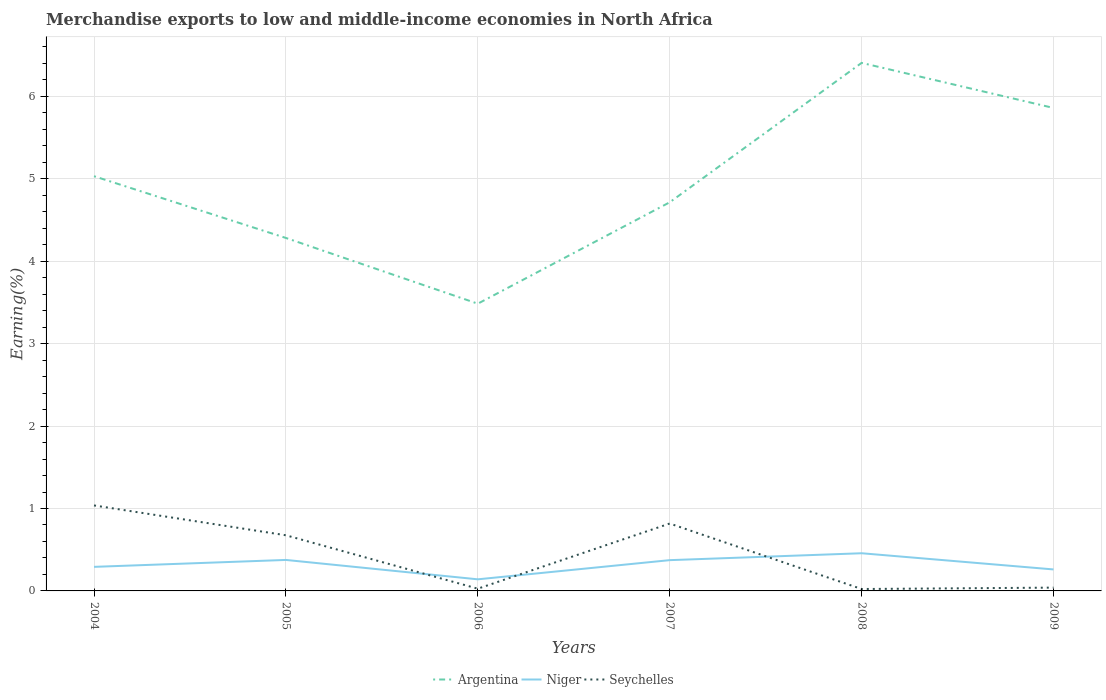How many different coloured lines are there?
Your answer should be very brief. 3. Does the line corresponding to Niger intersect with the line corresponding to Seychelles?
Provide a short and direct response. Yes. Is the number of lines equal to the number of legend labels?
Provide a succinct answer. Yes. Across all years, what is the maximum percentage of amount earned from merchandise exports in Niger?
Provide a succinct answer. 0.14. What is the total percentage of amount earned from merchandise exports in Niger in the graph?
Provide a short and direct response. -0.23. What is the difference between the highest and the second highest percentage of amount earned from merchandise exports in Niger?
Provide a short and direct response. 0.32. What is the difference between the highest and the lowest percentage of amount earned from merchandise exports in Seychelles?
Your answer should be compact. 3. Is the percentage of amount earned from merchandise exports in Seychelles strictly greater than the percentage of amount earned from merchandise exports in Niger over the years?
Make the answer very short. No. How many years are there in the graph?
Make the answer very short. 6. What is the difference between two consecutive major ticks on the Y-axis?
Offer a terse response. 1. Does the graph contain grids?
Your response must be concise. Yes. What is the title of the graph?
Your answer should be very brief. Merchandise exports to low and middle-income economies in North Africa. Does "Turks and Caicos Islands" appear as one of the legend labels in the graph?
Your answer should be very brief. No. What is the label or title of the X-axis?
Ensure brevity in your answer.  Years. What is the label or title of the Y-axis?
Provide a short and direct response. Earning(%). What is the Earning(%) in Argentina in 2004?
Ensure brevity in your answer.  5.03. What is the Earning(%) of Niger in 2004?
Provide a short and direct response. 0.29. What is the Earning(%) in Seychelles in 2004?
Offer a very short reply. 1.04. What is the Earning(%) in Argentina in 2005?
Your response must be concise. 4.28. What is the Earning(%) in Niger in 2005?
Your answer should be very brief. 0.38. What is the Earning(%) of Seychelles in 2005?
Give a very brief answer. 0.68. What is the Earning(%) in Argentina in 2006?
Your answer should be compact. 3.48. What is the Earning(%) of Niger in 2006?
Offer a very short reply. 0.14. What is the Earning(%) in Seychelles in 2006?
Your answer should be very brief. 0.03. What is the Earning(%) of Argentina in 2007?
Your response must be concise. 4.72. What is the Earning(%) in Niger in 2007?
Make the answer very short. 0.37. What is the Earning(%) in Seychelles in 2007?
Your response must be concise. 0.82. What is the Earning(%) in Argentina in 2008?
Keep it short and to the point. 6.41. What is the Earning(%) of Niger in 2008?
Offer a terse response. 0.46. What is the Earning(%) of Seychelles in 2008?
Your answer should be very brief. 0.02. What is the Earning(%) of Argentina in 2009?
Your answer should be very brief. 5.86. What is the Earning(%) in Niger in 2009?
Your answer should be very brief. 0.26. What is the Earning(%) in Seychelles in 2009?
Keep it short and to the point. 0.04. Across all years, what is the maximum Earning(%) in Argentina?
Your answer should be compact. 6.41. Across all years, what is the maximum Earning(%) in Niger?
Your response must be concise. 0.46. Across all years, what is the maximum Earning(%) of Seychelles?
Give a very brief answer. 1.04. Across all years, what is the minimum Earning(%) in Argentina?
Your answer should be very brief. 3.48. Across all years, what is the minimum Earning(%) in Niger?
Provide a succinct answer. 0.14. Across all years, what is the minimum Earning(%) of Seychelles?
Your response must be concise. 0.02. What is the total Earning(%) in Argentina in the graph?
Provide a short and direct response. 29.78. What is the total Earning(%) in Niger in the graph?
Offer a very short reply. 1.9. What is the total Earning(%) in Seychelles in the graph?
Your answer should be very brief. 2.62. What is the difference between the Earning(%) in Argentina in 2004 and that in 2005?
Give a very brief answer. 0.75. What is the difference between the Earning(%) of Niger in 2004 and that in 2005?
Your response must be concise. -0.08. What is the difference between the Earning(%) of Seychelles in 2004 and that in 2005?
Keep it short and to the point. 0.36. What is the difference between the Earning(%) in Argentina in 2004 and that in 2006?
Offer a very short reply. 1.55. What is the difference between the Earning(%) of Niger in 2004 and that in 2006?
Ensure brevity in your answer.  0.15. What is the difference between the Earning(%) in Seychelles in 2004 and that in 2006?
Provide a succinct answer. 1.01. What is the difference between the Earning(%) in Argentina in 2004 and that in 2007?
Your answer should be very brief. 0.32. What is the difference between the Earning(%) of Niger in 2004 and that in 2007?
Your response must be concise. -0.08. What is the difference between the Earning(%) in Seychelles in 2004 and that in 2007?
Your response must be concise. 0.22. What is the difference between the Earning(%) of Argentina in 2004 and that in 2008?
Offer a terse response. -1.37. What is the difference between the Earning(%) in Niger in 2004 and that in 2008?
Your answer should be compact. -0.17. What is the difference between the Earning(%) of Seychelles in 2004 and that in 2008?
Ensure brevity in your answer.  1.01. What is the difference between the Earning(%) in Argentina in 2004 and that in 2009?
Provide a succinct answer. -0.83. What is the difference between the Earning(%) in Niger in 2004 and that in 2009?
Your response must be concise. 0.03. What is the difference between the Earning(%) of Seychelles in 2004 and that in 2009?
Provide a short and direct response. 1. What is the difference between the Earning(%) in Argentina in 2005 and that in 2006?
Provide a short and direct response. 0.8. What is the difference between the Earning(%) of Niger in 2005 and that in 2006?
Your response must be concise. 0.24. What is the difference between the Earning(%) of Seychelles in 2005 and that in 2006?
Your response must be concise. 0.65. What is the difference between the Earning(%) in Argentina in 2005 and that in 2007?
Your response must be concise. -0.43. What is the difference between the Earning(%) in Niger in 2005 and that in 2007?
Provide a short and direct response. 0. What is the difference between the Earning(%) of Seychelles in 2005 and that in 2007?
Give a very brief answer. -0.14. What is the difference between the Earning(%) in Argentina in 2005 and that in 2008?
Make the answer very short. -2.12. What is the difference between the Earning(%) in Niger in 2005 and that in 2008?
Keep it short and to the point. -0.08. What is the difference between the Earning(%) of Seychelles in 2005 and that in 2008?
Give a very brief answer. 0.65. What is the difference between the Earning(%) in Argentina in 2005 and that in 2009?
Provide a short and direct response. -1.58. What is the difference between the Earning(%) of Niger in 2005 and that in 2009?
Make the answer very short. 0.12. What is the difference between the Earning(%) of Seychelles in 2005 and that in 2009?
Offer a very short reply. 0.64. What is the difference between the Earning(%) of Argentina in 2006 and that in 2007?
Keep it short and to the point. -1.23. What is the difference between the Earning(%) in Niger in 2006 and that in 2007?
Your answer should be very brief. -0.23. What is the difference between the Earning(%) in Seychelles in 2006 and that in 2007?
Your response must be concise. -0.79. What is the difference between the Earning(%) of Argentina in 2006 and that in 2008?
Your answer should be compact. -2.92. What is the difference between the Earning(%) in Niger in 2006 and that in 2008?
Make the answer very short. -0.32. What is the difference between the Earning(%) of Seychelles in 2006 and that in 2008?
Give a very brief answer. 0. What is the difference between the Earning(%) in Argentina in 2006 and that in 2009?
Give a very brief answer. -2.37. What is the difference between the Earning(%) of Niger in 2006 and that in 2009?
Provide a succinct answer. -0.12. What is the difference between the Earning(%) of Seychelles in 2006 and that in 2009?
Make the answer very short. -0.01. What is the difference between the Earning(%) of Argentina in 2007 and that in 2008?
Offer a very short reply. -1.69. What is the difference between the Earning(%) of Niger in 2007 and that in 2008?
Offer a terse response. -0.08. What is the difference between the Earning(%) in Seychelles in 2007 and that in 2008?
Give a very brief answer. 0.79. What is the difference between the Earning(%) in Argentina in 2007 and that in 2009?
Give a very brief answer. -1.14. What is the difference between the Earning(%) in Niger in 2007 and that in 2009?
Ensure brevity in your answer.  0.11. What is the difference between the Earning(%) in Seychelles in 2007 and that in 2009?
Provide a succinct answer. 0.78. What is the difference between the Earning(%) in Argentina in 2008 and that in 2009?
Your response must be concise. 0.55. What is the difference between the Earning(%) of Niger in 2008 and that in 2009?
Offer a terse response. 0.2. What is the difference between the Earning(%) of Seychelles in 2008 and that in 2009?
Provide a short and direct response. -0.02. What is the difference between the Earning(%) of Argentina in 2004 and the Earning(%) of Niger in 2005?
Give a very brief answer. 4.66. What is the difference between the Earning(%) in Argentina in 2004 and the Earning(%) in Seychelles in 2005?
Provide a short and direct response. 4.36. What is the difference between the Earning(%) of Niger in 2004 and the Earning(%) of Seychelles in 2005?
Provide a succinct answer. -0.38. What is the difference between the Earning(%) in Argentina in 2004 and the Earning(%) in Niger in 2006?
Make the answer very short. 4.89. What is the difference between the Earning(%) in Argentina in 2004 and the Earning(%) in Seychelles in 2006?
Provide a short and direct response. 5. What is the difference between the Earning(%) of Niger in 2004 and the Earning(%) of Seychelles in 2006?
Your answer should be very brief. 0.26. What is the difference between the Earning(%) in Argentina in 2004 and the Earning(%) in Niger in 2007?
Keep it short and to the point. 4.66. What is the difference between the Earning(%) in Argentina in 2004 and the Earning(%) in Seychelles in 2007?
Provide a succinct answer. 4.21. What is the difference between the Earning(%) of Niger in 2004 and the Earning(%) of Seychelles in 2007?
Your response must be concise. -0.53. What is the difference between the Earning(%) in Argentina in 2004 and the Earning(%) in Niger in 2008?
Make the answer very short. 4.57. What is the difference between the Earning(%) of Argentina in 2004 and the Earning(%) of Seychelles in 2008?
Your answer should be compact. 5.01. What is the difference between the Earning(%) in Niger in 2004 and the Earning(%) in Seychelles in 2008?
Offer a very short reply. 0.27. What is the difference between the Earning(%) in Argentina in 2004 and the Earning(%) in Niger in 2009?
Your response must be concise. 4.77. What is the difference between the Earning(%) of Argentina in 2004 and the Earning(%) of Seychelles in 2009?
Offer a very short reply. 4.99. What is the difference between the Earning(%) of Niger in 2004 and the Earning(%) of Seychelles in 2009?
Give a very brief answer. 0.25. What is the difference between the Earning(%) in Argentina in 2005 and the Earning(%) in Niger in 2006?
Provide a short and direct response. 4.14. What is the difference between the Earning(%) in Argentina in 2005 and the Earning(%) in Seychelles in 2006?
Your response must be concise. 4.26. What is the difference between the Earning(%) in Niger in 2005 and the Earning(%) in Seychelles in 2006?
Offer a very short reply. 0.35. What is the difference between the Earning(%) of Argentina in 2005 and the Earning(%) of Niger in 2007?
Provide a succinct answer. 3.91. What is the difference between the Earning(%) of Argentina in 2005 and the Earning(%) of Seychelles in 2007?
Your response must be concise. 3.46. What is the difference between the Earning(%) in Niger in 2005 and the Earning(%) in Seychelles in 2007?
Give a very brief answer. -0.44. What is the difference between the Earning(%) of Argentina in 2005 and the Earning(%) of Niger in 2008?
Ensure brevity in your answer.  3.83. What is the difference between the Earning(%) of Argentina in 2005 and the Earning(%) of Seychelles in 2008?
Give a very brief answer. 4.26. What is the difference between the Earning(%) of Niger in 2005 and the Earning(%) of Seychelles in 2008?
Give a very brief answer. 0.35. What is the difference between the Earning(%) of Argentina in 2005 and the Earning(%) of Niger in 2009?
Provide a succinct answer. 4.02. What is the difference between the Earning(%) in Argentina in 2005 and the Earning(%) in Seychelles in 2009?
Your answer should be very brief. 4.24. What is the difference between the Earning(%) in Niger in 2005 and the Earning(%) in Seychelles in 2009?
Make the answer very short. 0.34. What is the difference between the Earning(%) in Argentina in 2006 and the Earning(%) in Niger in 2007?
Make the answer very short. 3.11. What is the difference between the Earning(%) in Argentina in 2006 and the Earning(%) in Seychelles in 2007?
Give a very brief answer. 2.67. What is the difference between the Earning(%) of Niger in 2006 and the Earning(%) of Seychelles in 2007?
Give a very brief answer. -0.68. What is the difference between the Earning(%) in Argentina in 2006 and the Earning(%) in Niger in 2008?
Make the answer very short. 3.03. What is the difference between the Earning(%) in Argentina in 2006 and the Earning(%) in Seychelles in 2008?
Give a very brief answer. 3.46. What is the difference between the Earning(%) in Niger in 2006 and the Earning(%) in Seychelles in 2008?
Your answer should be compact. 0.12. What is the difference between the Earning(%) of Argentina in 2006 and the Earning(%) of Niger in 2009?
Keep it short and to the point. 3.22. What is the difference between the Earning(%) of Argentina in 2006 and the Earning(%) of Seychelles in 2009?
Your answer should be very brief. 3.44. What is the difference between the Earning(%) in Niger in 2006 and the Earning(%) in Seychelles in 2009?
Give a very brief answer. 0.1. What is the difference between the Earning(%) of Argentina in 2007 and the Earning(%) of Niger in 2008?
Give a very brief answer. 4.26. What is the difference between the Earning(%) of Argentina in 2007 and the Earning(%) of Seychelles in 2008?
Offer a terse response. 4.69. What is the difference between the Earning(%) of Niger in 2007 and the Earning(%) of Seychelles in 2008?
Your response must be concise. 0.35. What is the difference between the Earning(%) in Argentina in 2007 and the Earning(%) in Niger in 2009?
Your response must be concise. 4.45. What is the difference between the Earning(%) of Argentina in 2007 and the Earning(%) of Seychelles in 2009?
Ensure brevity in your answer.  4.68. What is the difference between the Earning(%) in Niger in 2007 and the Earning(%) in Seychelles in 2009?
Provide a short and direct response. 0.33. What is the difference between the Earning(%) in Argentina in 2008 and the Earning(%) in Niger in 2009?
Make the answer very short. 6.15. What is the difference between the Earning(%) in Argentina in 2008 and the Earning(%) in Seychelles in 2009?
Make the answer very short. 6.37. What is the difference between the Earning(%) in Niger in 2008 and the Earning(%) in Seychelles in 2009?
Provide a short and direct response. 0.42. What is the average Earning(%) in Argentina per year?
Offer a terse response. 4.96. What is the average Earning(%) of Niger per year?
Make the answer very short. 0.32. What is the average Earning(%) in Seychelles per year?
Provide a short and direct response. 0.44. In the year 2004, what is the difference between the Earning(%) in Argentina and Earning(%) in Niger?
Make the answer very short. 4.74. In the year 2004, what is the difference between the Earning(%) in Argentina and Earning(%) in Seychelles?
Your response must be concise. 3.99. In the year 2004, what is the difference between the Earning(%) of Niger and Earning(%) of Seychelles?
Your answer should be very brief. -0.75. In the year 2005, what is the difference between the Earning(%) of Argentina and Earning(%) of Niger?
Keep it short and to the point. 3.91. In the year 2005, what is the difference between the Earning(%) of Argentina and Earning(%) of Seychelles?
Offer a terse response. 3.61. In the year 2005, what is the difference between the Earning(%) of Niger and Earning(%) of Seychelles?
Your response must be concise. -0.3. In the year 2006, what is the difference between the Earning(%) in Argentina and Earning(%) in Niger?
Your response must be concise. 3.34. In the year 2006, what is the difference between the Earning(%) of Argentina and Earning(%) of Seychelles?
Offer a very short reply. 3.46. In the year 2006, what is the difference between the Earning(%) of Niger and Earning(%) of Seychelles?
Give a very brief answer. 0.11. In the year 2007, what is the difference between the Earning(%) in Argentina and Earning(%) in Niger?
Offer a very short reply. 4.34. In the year 2007, what is the difference between the Earning(%) in Argentina and Earning(%) in Seychelles?
Make the answer very short. 3.9. In the year 2007, what is the difference between the Earning(%) of Niger and Earning(%) of Seychelles?
Your answer should be compact. -0.44. In the year 2008, what is the difference between the Earning(%) in Argentina and Earning(%) in Niger?
Provide a short and direct response. 5.95. In the year 2008, what is the difference between the Earning(%) of Argentina and Earning(%) of Seychelles?
Your answer should be very brief. 6.38. In the year 2008, what is the difference between the Earning(%) of Niger and Earning(%) of Seychelles?
Offer a very short reply. 0.43. In the year 2009, what is the difference between the Earning(%) in Argentina and Earning(%) in Niger?
Provide a succinct answer. 5.6. In the year 2009, what is the difference between the Earning(%) of Argentina and Earning(%) of Seychelles?
Your answer should be very brief. 5.82. In the year 2009, what is the difference between the Earning(%) of Niger and Earning(%) of Seychelles?
Give a very brief answer. 0.22. What is the ratio of the Earning(%) of Argentina in 2004 to that in 2005?
Your answer should be very brief. 1.18. What is the ratio of the Earning(%) in Niger in 2004 to that in 2005?
Offer a terse response. 0.78. What is the ratio of the Earning(%) of Seychelles in 2004 to that in 2005?
Make the answer very short. 1.54. What is the ratio of the Earning(%) in Argentina in 2004 to that in 2006?
Your response must be concise. 1.44. What is the ratio of the Earning(%) of Niger in 2004 to that in 2006?
Provide a succinct answer. 2.07. What is the ratio of the Earning(%) in Seychelles in 2004 to that in 2006?
Offer a very short reply. 38.22. What is the ratio of the Earning(%) of Argentina in 2004 to that in 2007?
Offer a terse response. 1.07. What is the ratio of the Earning(%) of Niger in 2004 to that in 2007?
Make the answer very short. 0.78. What is the ratio of the Earning(%) of Seychelles in 2004 to that in 2007?
Your response must be concise. 1.27. What is the ratio of the Earning(%) in Argentina in 2004 to that in 2008?
Keep it short and to the point. 0.79. What is the ratio of the Earning(%) of Niger in 2004 to that in 2008?
Ensure brevity in your answer.  0.64. What is the ratio of the Earning(%) of Seychelles in 2004 to that in 2008?
Offer a very short reply. 44.8. What is the ratio of the Earning(%) of Argentina in 2004 to that in 2009?
Your answer should be compact. 0.86. What is the ratio of the Earning(%) in Niger in 2004 to that in 2009?
Give a very brief answer. 1.12. What is the ratio of the Earning(%) in Seychelles in 2004 to that in 2009?
Offer a very short reply. 25.91. What is the ratio of the Earning(%) in Argentina in 2005 to that in 2006?
Your response must be concise. 1.23. What is the ratio of the Earning(%) in Niger in 2005 to that in 2006?
Offer a very short reply. 2.67. What is the ratio of the Earning(%) of Seychelles in 2005 to that in 2006?
Give a very brief answer. 24.88. What is the ratio of the Earning(%) in Argentina in 2005 to that in 2007?
Keep it short and to the point. 0.91. What is the ratio of the Earning(%) of Niger in 2005 to that in 2007?
Your response must be concise. 1.01. What is the ratio of the Earning(%) of Seychelles in 2005 to that in 2007?
Offer a very short reply. 0.83. What is the ratio of the Earning(%) of Argentina in 2005 to that in 2008?
Your answer should be compact. 0.67. What is the ratio of the Earning(%) of Niger in 2005 to that in 2008?
Make the answer very short. 0.82. What is the ratio of the Earning(%) in Seychelles in 2005 to that in 2008?
Your response must be concise. 29.16. What is the ratio of the Earning(%) in Argentina in 2005 to that in 2009?
Make the answer very short. 0.73. What is the ratio of the Earning(%) of Niger in 2005 to that in 2009?
Ensure brevity in your answer.  1.44. What is the ratio of the Earning(%) of Seychelles in 2005 to that in 2009?
Your response must be concise. 16.86. What is the ratio of the Earning(%) of Argentina in 2006 to that in 2007?
Keep it short and to the point. 0.74. What is the ratio of the Earning(%) in Niger in 2006 to that in 2007?
Provide a short and direct response. 0.38. What is the ratio of the Earning(%) in Seychelles in 2006 to that in 2007?
Keep it short and to the point. 0.03. What is the ratio of the Earning(%) in Argentina in 2006 to that in 2008?
Make the answer very short. 0.54. What is the ratio of the Earning(%) of Niger in 2006 to that in 2008?
Give a very brief answer. 0.31. What is the ratio of the Earning(%) of Seychelles in 2006 to that in 2008?
Offer a terse response. 1.17. What is the ratio of the Earning(%) of Argentina in 2006 to that in 2009?
Provide a short and direct response. 0.59. What is the ratio of the Earning(%) of Niger in 2006 to that in 2009?
Give a very brief answer. 0.54. What is the ratio of the Earning(%) of Seychelles in 2006 to that in 2009?
Provide a succinct answer. 0.68. What is the ratio of the Earning(%) of Argentina in 2007 to that in 2008?
Provide a short and direct response. 0.74. What is the ratio of the Earning(%) of Niger in 2007 to that in 2008?
Keep it short and to the point. 0.82. What is the ratio of the Earning(%) of Seychelles in 2007 to that in 2008?
Your answer should be very brief. 35.31. What is the ratio of the Earning(%) in Argentina in 2007 to that in 2009?
Provide a short and direct response. 0.8. What is the ratio of the Earning(%) in Niger in 2007 to that in 2009?
Keep it short and to the point. 1.43. What is the ratio of the Earning(%) in Seychelles in 2007 to that in 2009?
Ensure brevity in your answer.  20.42. What is the ratio of the Earning(%) of Argentina in 2008 to that in 2009?
Provide a short and direct response. 1.09. What is the ratio of the Earning(%) in Niger in 2008 to that in 2009?
Make the answer very short. 1.75. What is the ratio of the Earning(%) of Seychelles in 2008 to that in 2009?
Provide a short and direct response. 0.58. What is the difference between the highest and the second highest Earning(%) of Argentina?
Provide a short and direct response. 0.55. What is the difference between the highest and the second highest Earning(%) in Niger?
Provide a short and direct response. 0.08. What is the difference between the highest and the second highest Earning(%) in Seychelles?
Offer a terse response. 0.22. What is the difference between the highest and the lowest Earning(%) in Argentina?
Give a very brief answer. 2.92. What is the difference between the highest and the lowest Earning(%) of Niger?
Ensure brevity in your answer.  0.32. What is the difference between the highest and the lowest Earning(%) of Seychelles?
Give a very brief answer. 1.01. 